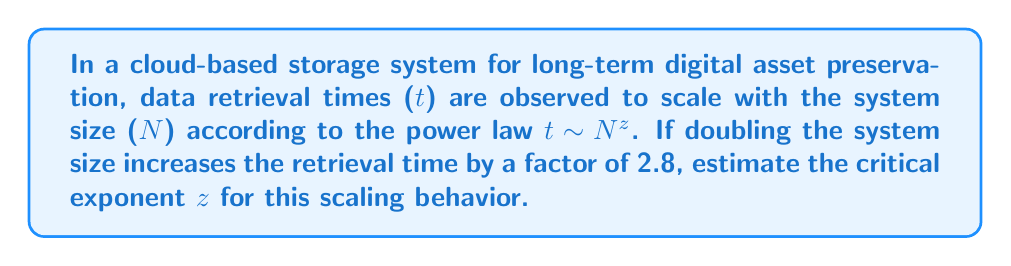Solve this math problem. To solve this problem, we'll follow these steps:

1) The scaling behavior is described by the power law:
   
   $t \sim N^z$

2) When we double the system size, we can write:
   
   $\frac{t(2N)}{t(N)} = \frac{(2N)^z}{N^z} = 2^z$

3) We're told that doubling the system size increases the retrieval time by a factor of 2.8. This means:

   $2^z = 2.8$

4) To solve for $z$, we take the logarithm (base 2) of both sides:

   $\log_2(2^z) = \log_2(2.8)$

5) Simplify the left side:

   $z = \log_2(2.8)$

6) Calculate the value:

   $z \approx 1.4854$

Therefore, the critical exponent $z$ for the scaling behavior of data retrieval times in this storage architecture is approximately 1.4854.
Answer: $z \approx 1.4854$ 